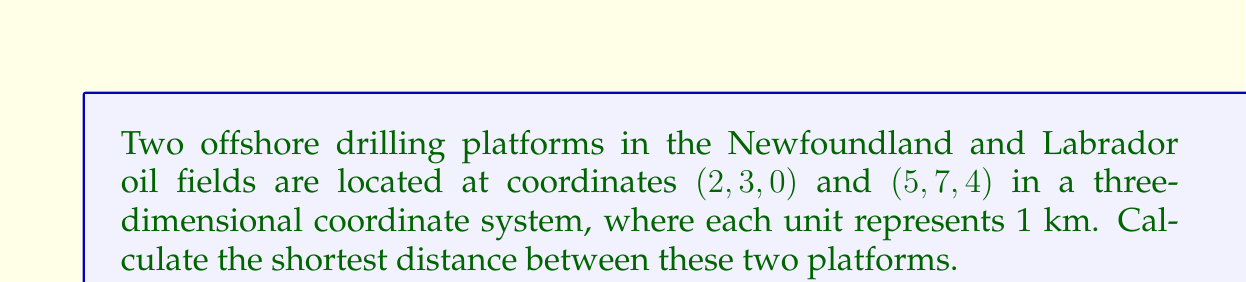Give your solution to this math problem. To find the shortest distance between two points in three-dimensional space, we can use the distance formula:

$$d = \sqrt{(x_2-x_1)^2 + (y_2-y_1)^2 + (z_2-z_1)^2}$$

Where $(x_1, y_1, z_1)$ are the coordinates of the first point and $(x_2, y_2, z_2)$ are the coordinates of the second point.

Let's substitute the given coordinates:
$(x_1, y_1, z_1) = (2, 3, 0)$
$(x_2, y_2, z_2) = (5, 7, 4)$

Now, let's calculate each term inside the square root:

1. $(x_2-x_1)^2 = (5-2)^2 = 3^2 = 9$
2. $(y_2-y_1)^2 = (7-3)^2 = 4^2 = 16$
3. $(z_2-z_1)^2 = (4-0)^2 = 4^2 = 16$

Substituting these values into the formula:

$$d = \sqrt{9 + 16 + 16}$$
$$d = \sqrt{41}$$

The square root of 41 is approximately 6.403 km.

[asy]
import three;
size(200);
currentprojection=perspective(6,3,2);
draw(O--6X,gray+dashed);
draw(O--8Y,gray+dashed);
draw(O--5Z,gray+dashed);
dot((2,3,0),red);
dot((5,7,4),red);
draw((2,3,0)--(5,7,4),blue);
label("(2,3,0)",(2,3,0),SW);
label("(5,7,4)",(5,7,4),NE);
[/asy]
Answer: $\sqrt{41}$ km $\approx 6.403$ km 